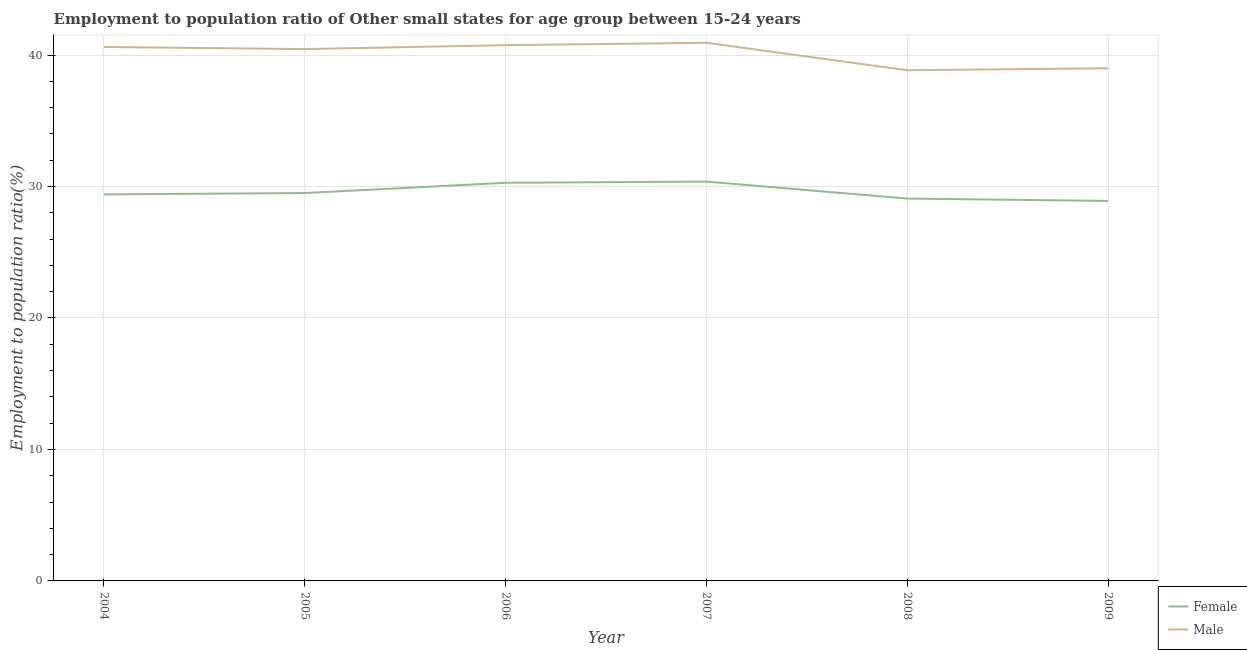How many different coloured lines are there?
Provide a short and direct response. 2. Is the number of lines equal to the number of legend labels?
Provide a short and direct response. Yes. What is the employment to population ratio(female) in 2006?
Ensure brevity in your answer.  30.28. Across all years, what is the maximum employment to population ratio(female)?
Give a very brief answer. 30.38. Across all years, what is the minimum employment to population ratio(male)?
Offer a very short reply. 38.85. In which year was the employment to population ratio(female) maximum?
Offer a terse response. 2007. What is the total employment to population ratio(female) in the graph?
Your answer should be compact. 177.56. What is the difference between the employment to population ratio(female) in 2006 and that in 2009?
Ensure brevity in your answer.  1.38. What is the difference between the employment to population ratio(female) in 2009 and the employment to population ratio(male) in 2005?
Provide a succinct answer. -11.55. What is the average employment to population ratio(male) per year?
Give a very brief answer. 40.1. In the year 2006, what is the difference between the employment to population ratio(female) and employment to population ratio(male)?
Your answer should be compact. -10.47. In how many years, is the employment to population ratio(male) greater than 38 %?
Keep it short and to the point. 6. What is the ratio of the employment to population ratio(female) in 2005 to that in 2006?
Offer a terse response. 0.97. Is the difference between the employment to population ratio(male) in 2004 and 2005 greater than the difference between the employment to population ratio(female) in 2004 and 2005?
Your answer should be compact. Yes. What is the difference between the highest and the second highest employment to population ratio(female)?
Ensure brevity in your answer.  0.09. What is the difference between the highest and the lowest employment to population ratio(male)?
Offer a terse response. 2.09. In how many years, is the employment to population ratio(male) greater than the average employment to population ratio(male) taken over all years?
Provide a succinct answer. 4. Does the employment to population ratio(male) monotonically increase over the years?
Give a very brief answer. No. Are the values on the major ticks of Y-axis written in scientific E-notation?
Ensure brevity in your answer.  No. Does the graph contain grids?
Make the answer very short. Yes. How many legend labels are there?
Provide a short and direct response. 2. How are the legend labels stacked?
Provide a short and direct response. Vertical. What is the title of the graph?
Ensure brevity in your answer.  Employment to population ratio of Other small states for age group between 15-24 years. What is the label or title of the Y-axis?
Your answer should be compact. Employment to population ratio(%). What is the Employment to population ratio(%) in Female in 2004?
Ensure brevity in your answer.  29.4. What is the Employment to population ratio(%) of Male in 2004?
Make the answer very short. 40.61. What is the Employment to population ratio(%) of Female in 2005?
Provide a succinct answer. 29.5. What is the Employment to population ratio(%) in Male in 2005?
Your answer should be very brief. 40.45. What is the Employment to population ratio(%) in Female in 2006?
Ensure brevity in your answer.  30.28. What is the Employment to population ratio(%) of Male in 2006?
Give a very brief answer. 40.75. What is the Employment to population ratio(%) of Female in 2007?
Ensure brevity in your answer.  30.38. What is the Employment to population ratio(%) of Male in 2007?
Your answer should be compact. 40.93. What is the Employment to population ratio(%) of Female in 2008?
Keep it short and to the point. 29.08. What is the Employment to population ratio(%) of Male in 2008?
Give a very brief answer. 38.85. What is the Employment to population ratio(%) in Female in 2009?
Ensure brevity in your answer.  28.9. What is the Employment to population ratio(%) in Male in 2009?
Provide a succinct answer. 39. Across all years, what is the maximum Employment to population ratio(%) in Female?
Your answer should be compact. 30.38. Across all years, what is the maximum Employment to population ratio(%) of Male?
Ensure brevity in your answer.  40.93. Across all years, what is the minimum Employment to population ratio(%) in Female?
Your answer should be very brief. 28.9. Across all years, what is the minimum Employment to population ratio(%) of Male?
Keep it short and to the point. 38.85. What is the total Employment to population ratio(%) of Female in the graph?
Provide a succinct answer. 177.56. What is the total Employment to population ratio(%) of Male in the graph?
Offer a very short reply. 240.6. What is the difference between the Employment to population ratio(%) of Female in 2004 and that in 2005?
Offer a very short reply. -0.1. What is the difference between the Employment to population ratio(%) of Male in 2004 and that in 2005?
Ensure brevity in your answer.  0.16. What is the difference between the Employment to population ratio(%) in Female in 2004 and that in 2006?
Ensure brevity in your answer.  -0.88. What is the difference between the Employment to population ratio(%) in Male in 2004 and that in 2006?
Your answer should be compact. -0.14. What is the difference between the Employment to population ratio(%) of Female in 2004 and that in 2007?
Your answer should be very brief. -0.97. What is the difference between the Employment to population ratio(%) of Male in 2004 and that in 2007?
Keep it short and to the point. -0.32. What is the difference between the Employment to population ratio(%) of Female in 2004 and that in 2008?
Keep it short and to the point. 0.32. What is the difference between the Employment to population ratio(%) in Male in 2004 and that in 2008?
Make the answer very short. 1.77. What is the difference between the Employment to population ratio(%) in Female in 2004 and that in 2009?
Your answer should be compact. 0.5. What is the difference between the Employment to population ratio(%) of Male in 2004 and that in 2009?
Ensure brevity in your answer.  1.62. What is the difference between the Employment to population ratio(%) of Female in 2005 and that in 2006?
Your answer should be very brief. -0.78. What is the difference between the Employment to population ratio(%) of Male in 2005 and that in 2006?
Your response must be concise. -0.3. What is the difference between the Employment to population ratio(%) of Female in 2005 and that in 2007?
Your answer should be very brief. -0.87. What is the difference between the Employment to population ratio(%) of Male in 2005 and that in 2007?
Provide a succinct answer. -0.48. What is the difference between the Employment to population ratio(%) of Female in 2005 and that in 2008?
Make the answer very short. 0.42. What is the difference between the Employment to population ratio(%) in Male in 2005 and that in 2008?
Ensure brevity in your answer.  1.61. What is the difference between the Employment to population ratio(%) in Female in 2005 and that in 2009?
Offer a terse response. 0.6. What is the difference between the Employment to population ratio(%) in Male in 2005 and that in 2009?
Provide a short and direct response. 1.46. What is the difference between the Employment to population ratio(%) in Female in 2006 and that in 2007?
Your answer should be compact. -0.09. What is the difference between the Employment to population ratio(%) of Male in 2006 and that in 2007?
Offer a terse response. -0.18. What is the difference between the Employment to population ratio(%) in Female in 2006 and that in 2008?
Give a very brief answer. 1.2. What is the difference between the Employment to population ratio(%) in Male in 2006 and that in 2008?
Offer a terse response. 1.91. What is the difference between the Employment to population ratio(%) in Female in 2006 and that in 2009?
Provide a succinct answer. 1.38. What is the difference between the Employment to population ratio(%) of Male in 2006 and that in 2009?
Offer a very short reply. 1.76. What is the difference between the Employment to population ratio(%) of Female in 2007 and that in 2008?
Your answer should be compact. 1.29. What is the difference between the Employment to population ratio(%) in Male in 2007 and that in 2008?
Ensure brevity in your answer.  2.09. What is the difference between the Employment to population ratio(%) of Female in 2007 and that in 2009?
Your answer should be compact. 1.47. What is the difference between the Employment to population ratio(%) of Male in 2007 and that in 2009?
Make the answer very short. 1.94. What is the difference between the Employment to population ratio(%) of Female in 2008 and that in 2009?
Offer a terse response. 0.18. What is the difference between the Employment to population ratio(%) in Male in 2008 and that in 2009?
Your answer should be compact. -0.15. What is the difference between the Employment to population ratio(%) in Female in 2004 and the Employment to population ratio(%) in Male in 2005?
Ensure brevity in your answer.  -11.05. What is the difference between the Employment to population ratio(%) of Female in 2004 and the Employment to population ratio(%) of Male in 2006?
Keep it short and to the point. -11.35. What is the difference between the Employment to population ratio(%) in Female in 2004 and the Employment to population ratio(%) in Male in 2007?
Ensure brevity in your answer.  -11.53. What is the difference between the Employment to population ratio(%) in Female in 2004 and the Employment to population ratio(%) in Male in 2008?
Offer a very short reply. -9.44. What is the difference between the Employment to population ratio(%) of Female in 2004 and the Employment to population ratio(%) of Male in 2009?
Offer a very short reply. -9.59. What is the difference between the Employment to population ratio(%) of Female in 2005 and the Employment to population ratio(%) of Male in 2006?
Your response must be concise. -11.25. What is the difference between the Employment to population ratio(%) of Female in 2005 and the Employment to population ratio(%) of Male in 2007?
Give a very brief answer. -11.43. What is the difference between the Employment to population ratio(%) of Female in 2005 and the Employment to population ratio(%) of Male in 2008?
Offer a very short reply. -9.34. What is the difference between the Employment to population ratio(%) in Female in 2005 and the Employment to population ratio(%) in Male in 2009?
Keep it short and to the point. -9.49. What is the difference between the Employment to population ratio(%) of Female in 2006 and the Employment to population ratio(%) of Male in 2007?
Provide a succinct answer. -10.65. What is the difference between the Employment to population ratio(%) in Female in 2006 and the Employment to population ratio(%) in Male in 2008?
Provide a short and direct response. -8.56. What is the difference between the Employment to population ratio(%) in Female in 2006 and the Employment to population ratio(%) in Male in 2009?
Your answer should be compact. -8.71. What is the difference between the Employment to population ratio(%) of Female in 2007 and the Employment to population ratio(%) of Male in 2008?
Offer a terse response. -8.47. What is the difference between the Employment to population ratio(%) of Female in 2007 and the Employment to population ratio(%) of Male in 2009?
Make the answer very short. -8.62. What is the difference between the Employment to population ratio(%) in Female in 2008 and the Employment to population ratio(%) in Male in 2009?
Provide a succinct answer. -9.91. What is the average Employment to population ratio(%) in Female per year?
Give a very brief answer. 29.59. What is the average Employment to population ratio(%) in Male per year?
Offer a very short reply. 40.1. In the year 2004, what is the difference between the Employment to population ratio(%) of Female and Employment to population ratio(%) of Male?
Ensure brevity in your answer.  -11.21. In the year 2005, what is the difference between the Employment to population ratio(%) of Female and Employment to population ratio(%) of Male?
Offer a terse response. -10.95. In the year 2006, what is the difference between the Employment to population ratio(%) in Female and Employment to population ratio(%) in Male?
Your answer should be compact. -10.47. In the year 2007, what is the difference between the Employment to population ratio(%) of Female and Employment to population ratio(%) of Male?
Give a very brief answer. -10.56. In the year 2008, what is the difference between the Employment to population ratio(%) in Female and Employment to population ratio(%) in Male?
Provide a succinct answer. -9.76. In the year 2009, what is the difference between the Employment to population ratio(%) in Female and Employment to population ratio(%) in Male?
Give a very brief answer. -10.09. What is the ratio of the Employment to population ratio(%) of Female in 2004 to that in 2006?
Make the answer very short. 0.97. What is the ratio of the Employment to population ratio(%) in Male in 2004 to that in 2008?
Your answer should be compact. 1.05. What is the ratio of the Employment to population ratio(%) in Female in 2004 to that in 2009?
Give a very brief answer. 1.02. What is the ratio of the Employment to population ratio(%) of Male in 2004 to that in 2009?
Offer a terse response. 1.04. What is the ratio of the Employment to population ratio(%) in Female in 2005 to that in 2006?
Give a very brief answer. 0.97. What is the ratio of the Employment to population ratio(%) of Female in 2005 to that in 2007?
Provide a short and direct response. 0.97. What is the ratio of the Employment to population ratio(%) of Male in 2005 to that in 2007?
Ensure brevity in your answer.  0.99. What is the ratio of the Employment to population ratio(%) in Female in 2005 to that in 2008?
Keep it short and to the point. 1.01. What is the ratio of the Employment to population ratio(%) in Male in 2005 to that in 2008?
Your response must be concise. 1.04. What is the ratio of the Employment to population ratio(%) in Female in 2005 to that in 2009?
Offer a very short reply. 1.02. What is the ratio of the Employment to population ratio(%) of Male in 2005 to that in 2009?
Your answer should be compact. 1.04. What is the ratio of the Employment to population ratio(%) of Female in 2006 to that in 2007?
Provide a short and direct response. 1. What is the ratio of the Employment to population ratio(%) in Female in 2006 to that in 2008?
Offer a terse response. 1.04. What is the ratio of the Employment to population ratio(%) in Male in 2006 to that in 2008?
Your response must be concise. 1.05. What is the ratio of the Employment to population ratio(%) in Female in 2006 to that in 2009?
Offer a very short reply. 1.05. What is the ratio of the Employment to population ratio(%) in Male in 2006 to that in 2009?
Your answer should be compact. 1.05. What is the ratio of the Employment to population ratio(%) in Female in 2007 to that in 2008?
Your answer should be compact. 1.04. What is the ratio of the Employment to population ratio(%) in Male in 2007 to that in 2008?
Provide a short and direct response. 1.05. What is the ratio of the Employment to population ratio(%) of Female in 2007 to that in 2009?
Your response must be concise. 1.05. What is the ratio of the Employment to population ratio(%) in Male in 2007 to that in 2009?
Provide a succinct answer. 1.05. What is the ratio of the Employment to population ratio(%) in Female in 2008 to that in 2009?
Your answer should be compact. 1.01. What is the ratio of the Employment to population ratio(%) of Male in 2008 to that in 2009?
Your response must be concise. 1. What is the difference between the highest and the second highest Employment to population ratio(%) in Female?
Give a very brief answer. 0.09. What is the difference between the highest and the second highest Employment to population ratio(%) of Male?
Offer a very short reply. 0.18. What is the difference between the highest and the lowest Employment to population ratio(%) of Female?
Your response must be concise. 1.47. What is the difference between the highest and the lowest Employment to population ratio(%) in Male?
Give a very brief answer. 2.09. 